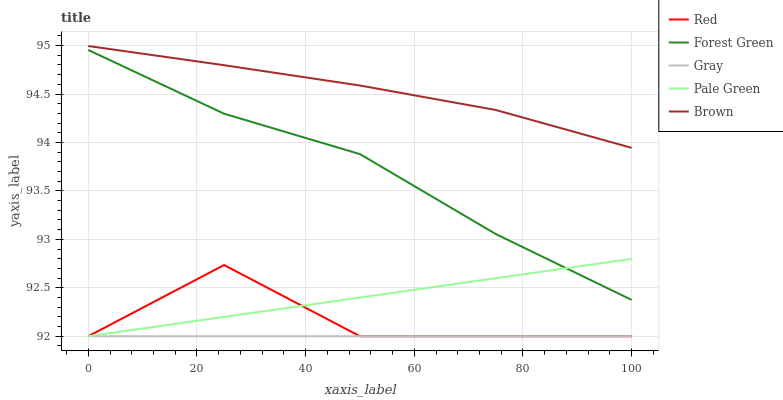Does Gray have the minimum area under the curve?
Answer yes or no. Yes. Does Brown have the maximum area under the curve?
Answer yes or no. Yes. Does Forest Green have the minimum area under the curve?
Answer yes or no. No. Does Forest Green have the maximum area under the curve?
Answer yes or no. No. Is Gray the smoothest?
Answer yes or no. Yes. Is Red the roughest?
Answer yes or no. Yes. Is Forest Green the smoothest?
Answer yes or no. No. Is Forest Green the roughest?
Answer yes or no. No. Does Gray have the lowest value?
Answer yes or no. Yes. Does Forest Green have the lowest value?
Answer yes or no. No. Does Brown have the highest value?
Answer yes or no. Yes. Does Forest Green have the highest value?
Answer yes or no. No. Is Gray less than Brown?
Answer yes or no. Yes. Is Forest Green greater than Gray?
Answer yes or no. Yes. Does Gray intersect Pale Green?
Answer yes or no. Yes. Is Gray less than Pale Green?
Answer yes or no. No. Is Gray greater than Pale Green?
Answer yes or no. No. Does Gray intersect Brown?
Answer yes or no. No. 